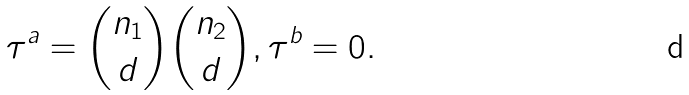Convert formula to latex. <formula><loc_0><loc_0><loc_500><loc_500>\tau ^ { a } = { n _ { 1 } \choose d } { n _ { 2 } \choose d } , \tau ^ { b } = 0 .</formula> 